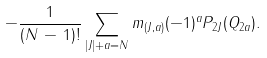<formula> <loc_0><loc_0><loc_500><loc_500>- \frac { 1 } { ( N \, - \, 1 ) ! } \sum _ { | J | + a = N } m _ { ( J , a ) } ( - 1 ) ^ { a } P _ { 2 J } ( Q _ { 2 a } ) .</formula> 